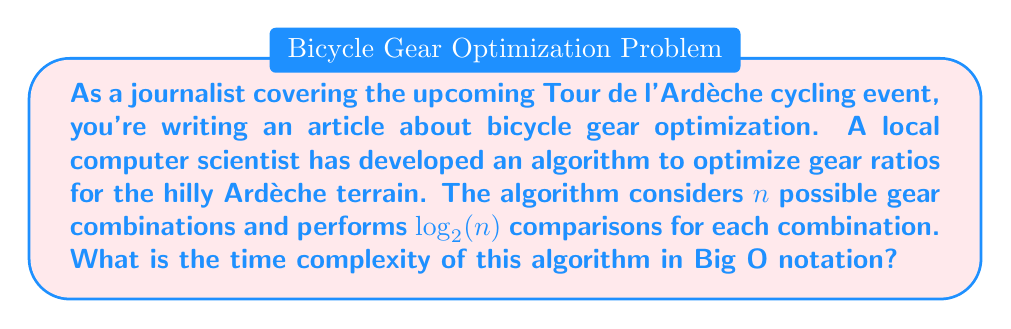Solve this math problem. To determine the time complexity of this algorithm, let's break it down step by step:

1. The algorithm considers $n$ possible gear combinations. This suggests we'll be iterating through all $n$ combinations.

2. For each combination, the algorithm performs $\log_2(n)$ comparisons. This is typically seen in divide-and-conquer algorithms or binary search operations.

3. To calculate the total number of operations, we multiply the number of combinations by the number of comparisons per combination:

   $n \cdot \log_2(n)$

4. In Big O notation, we express this as $O(n \log n)$.

5. This complexity is often referred to as "linearithmic" and is common in efficient sorting algorithms like mergesort and heapsort.

6. It's more efficient than quadratic time $O(n^2)$ for large inputs, but less efficient than linear time $O(n)$.

7. In the context of gear optimization, this algorithm would be quite efficient, allowing for a large number of gear combinations to be evaluated relatively quickly, which is crucial for real-time adjustments during a race in the varied terrain of Ardèche.
Answer: $O(n \log n)$ 